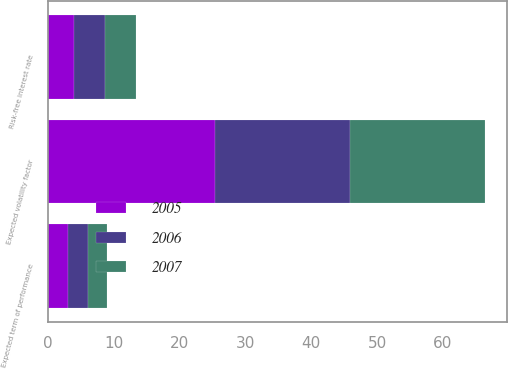<chart> <loc_0><loc_0><loc_500><loc_500><stacked_bar_chart><ecel><fcel>Expected term of performance<fcel>Expected volatility factor<fcel>Risk-free interest rate<nl><fcel>2007<fcel>3<fcel>20.52<fcel>4.73<nl><fcel>2006<fcel>3<fcel>20.54<fcel>4.67<nl><fcel>2005<fcel>3<fcel>25.37<fcel>3.91<nl></chart> 